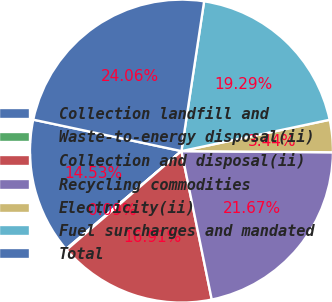Convert chart to OTSL. <chart><loc_0><loc_0><loc_500><loc_500><pie_chart><fcel>Collection landfill and<fcel>Waste-to-energy disposal(ii)<fcel>Collection and disposal(ii)<fcel>Recycling commodities<fcel>Electricity(ii)<fcel>Fuel surcharges and mandated<fcel>Total<nl><fcel>14.53%<fcel>0.09%<fcel>16.91%<fcel>21.67%<fcel>3.44%<fcel>19.29%<fcel>24.06%<nl></chart> 